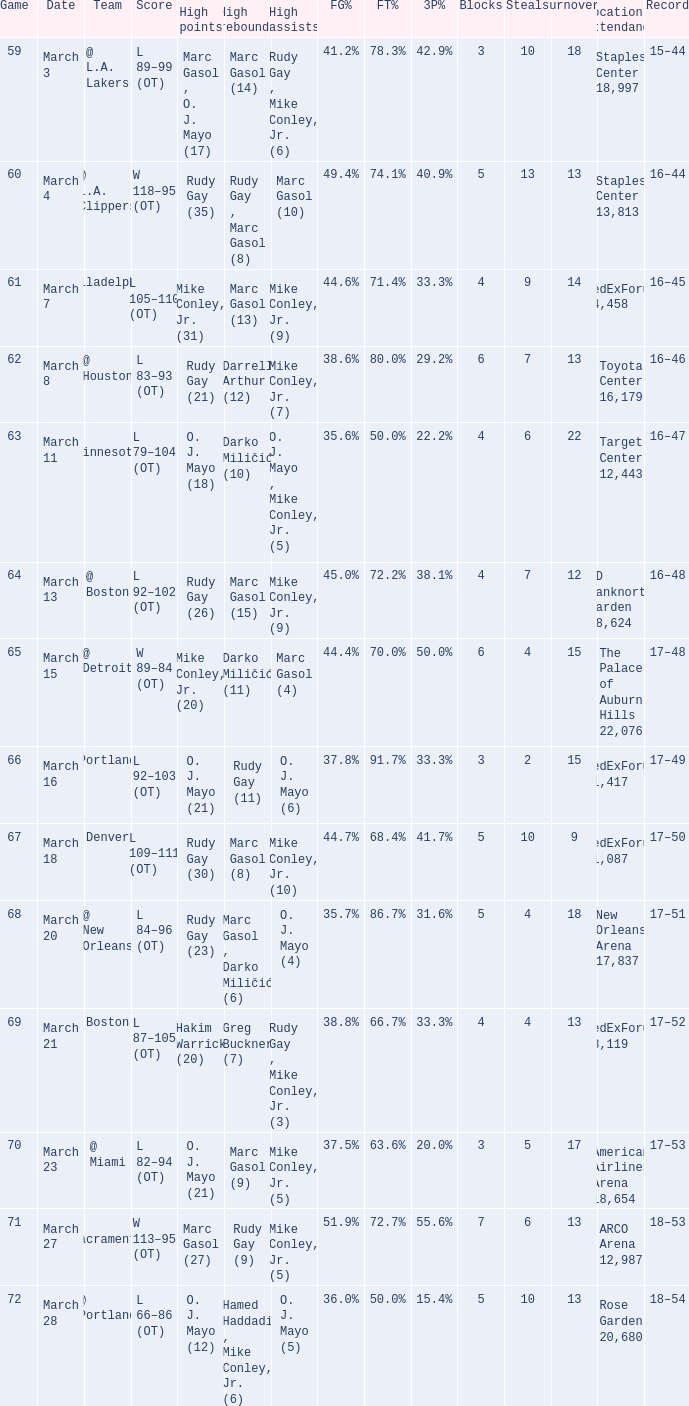Who had the highest assists on March 18? Mike Conley, Jr. (10). 